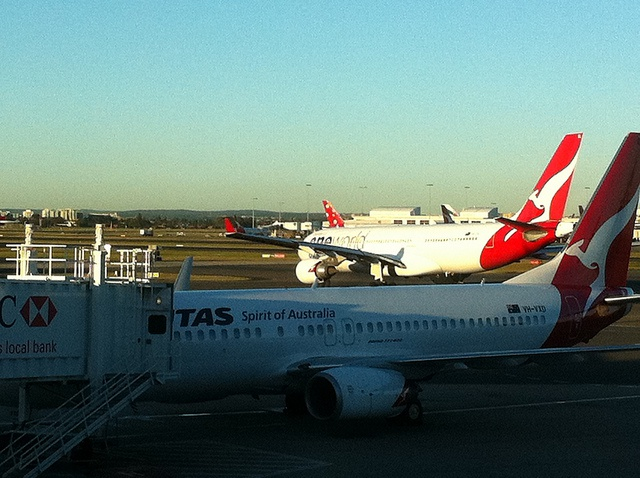Describe the objects in this image and their specific colors. I can see airplane in lightblue, black, blue, darkblue, and gray tones, airplane in lightblue, beige, red, black, and khaki tones, airplane in lightblue, red, tan, and beige tones, and airplane in lightblue, gray, black, purple, and maroon tones in this image. 